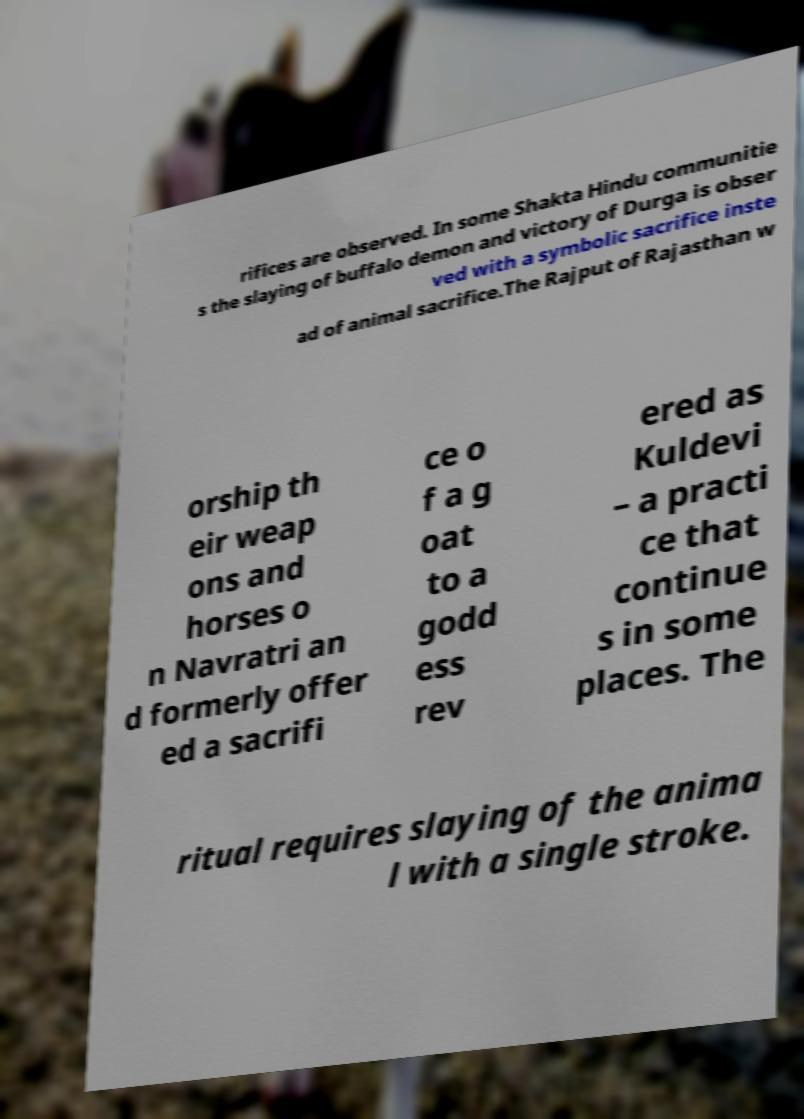Can you accurately transcribe the text from the provided image for me? rifices are observed. In some Shakta Hindu communitie s the slaying of buffalo demon and victory of Durga is obser ved with a symbolic sacrifice inste ad of animal sacrifice.The Rajput of Rajasthan w orship th eir weap ons and horses o n Navratri an d formerly offer ed a sacrifi ce o f a g oat to a godd ess rev ered as Kuldevi – a practi ce that continue s in some places. The ritual requires slaying of the anima l with a single stroke. 